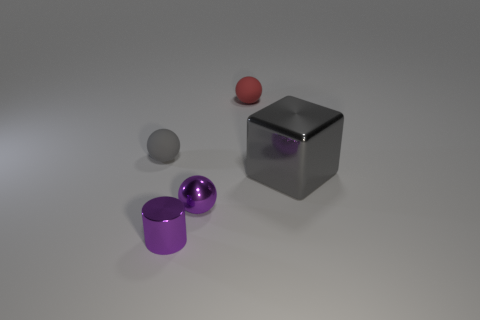Add 3 small red shiny cylinders. How many objects exist? 8 Subtract all cylinders. How many objects are left? 4 Subtract all small purple cylinders. Subtract all gray metallic cubes. How many objects are left? 3 Add 4 big gray blocks. How many big gray blocks are left? 5 Add 5 metallic cylinders. How many metallic cylinders exist? 6 Subtract 0 cyan cylinders. How many objects are left? 5 